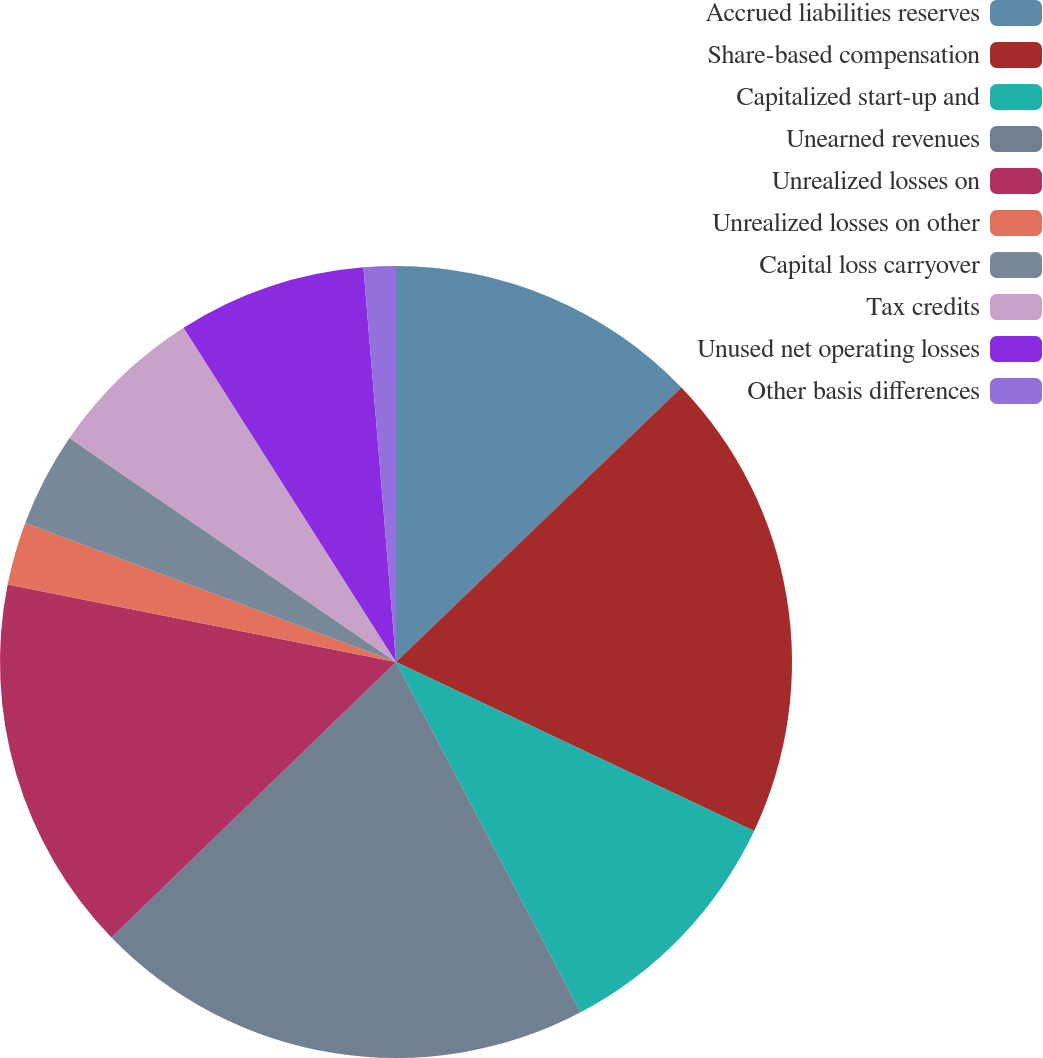<chart> <loc_0><loc_0><loc_500><loc_500><pie_chart><fcel>Accrued liabilities reserves<fcel>Share-based compensation<fcel>Capitalized start-up and<fcel>Unearned revenues<fcel>Unrealized losses on<fcel>Unrealized losses on other<fcel>Capital loss carryover<fcel>Tax credits<fcel>Unused net operating losses<fcel>Other basis differences<nl><fcel>12.81%<fcel>19.21%<fcel>10.26%<fcel>20.48%<fcel>15.37%<fcel>2.58%<fcel>3.86%<fcel>6.42%<fcel>7.7%<fcel>1.31%<nl></chart> 